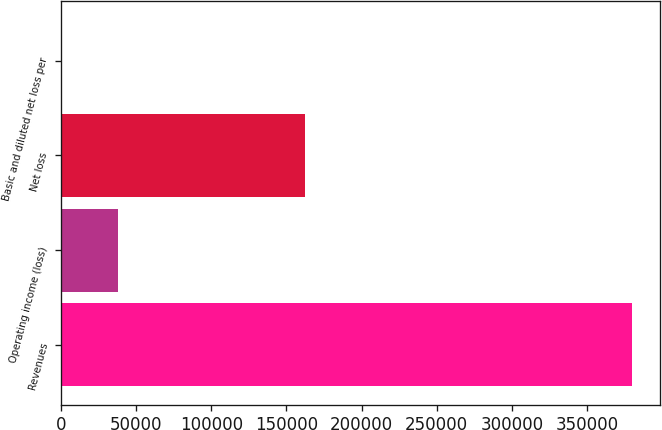Convert chart to OTSL. <chart><loc_0><loc_0><loc_500><loc_500><bar_chart><fcel>Revenues<fcel>Operating income (loss)<fcel>Net loss<fcel>Basic and diluted net loss per<nl><fcel>379863<fcel>37987.7<fcel>162573<fcel>1.57<nl></chart> 